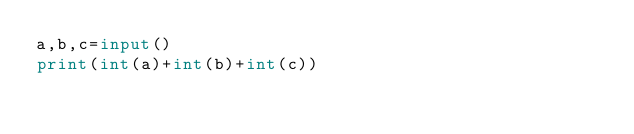Convert code to text. <code><loc_0><loc_0><loc_500><loc_500><_Python_>a,b,c=input()
print(int(a)+int(b)+int(c))</code> 